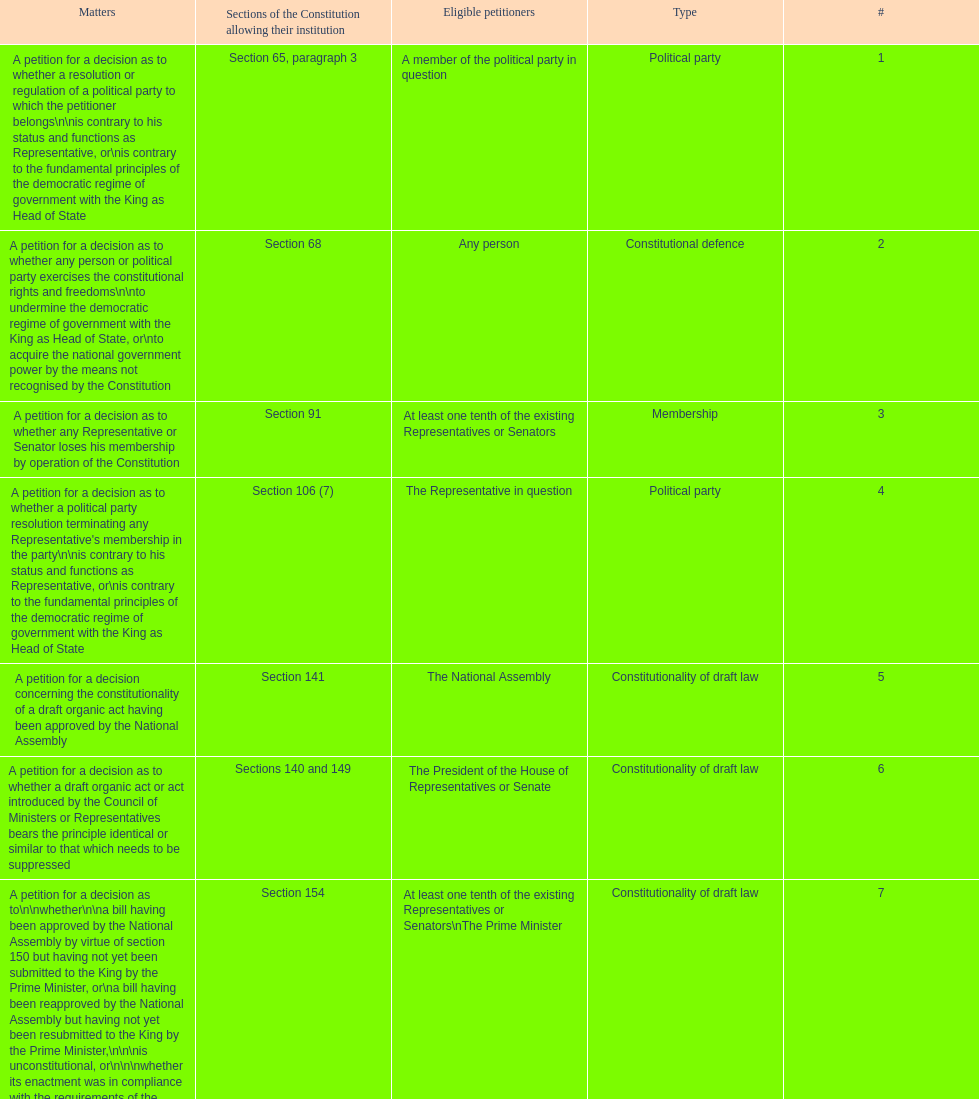How many matters have political party as their "type"? 3. 